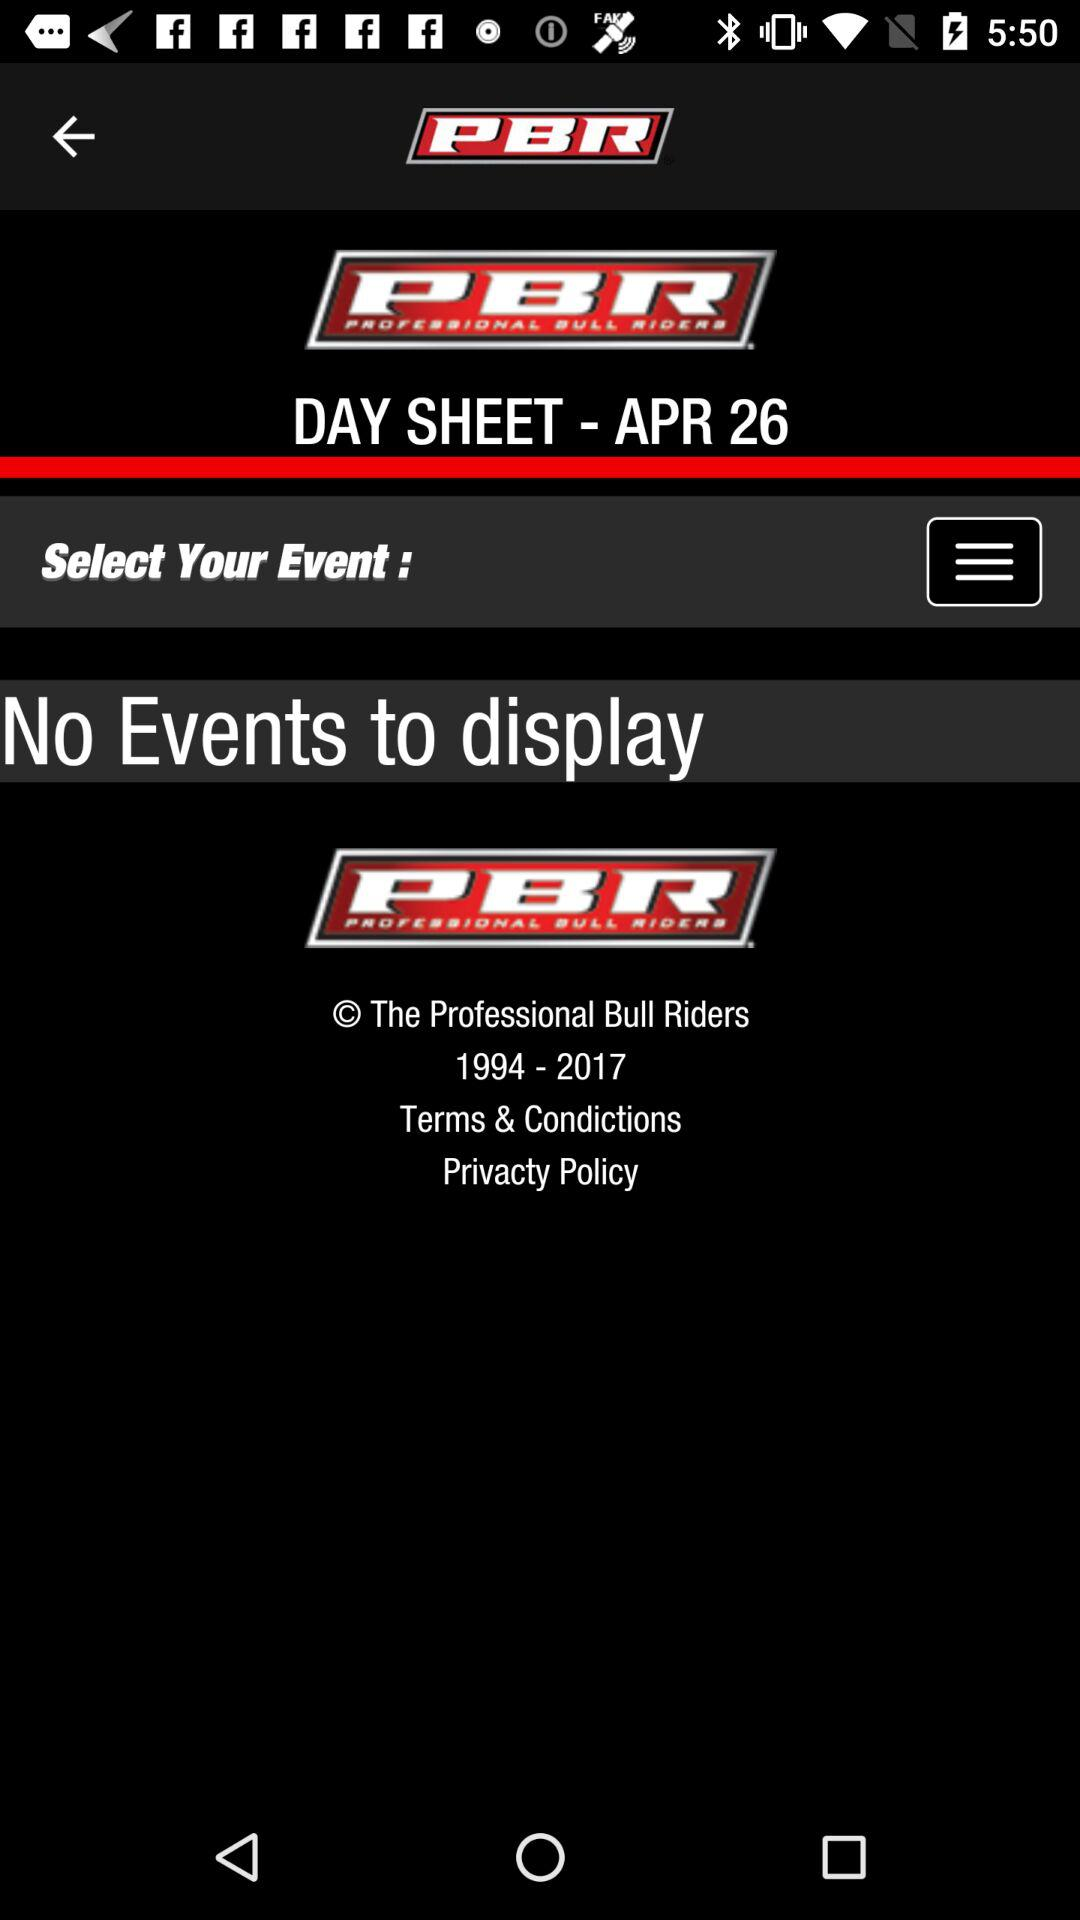What is the date? The date is April 26. 